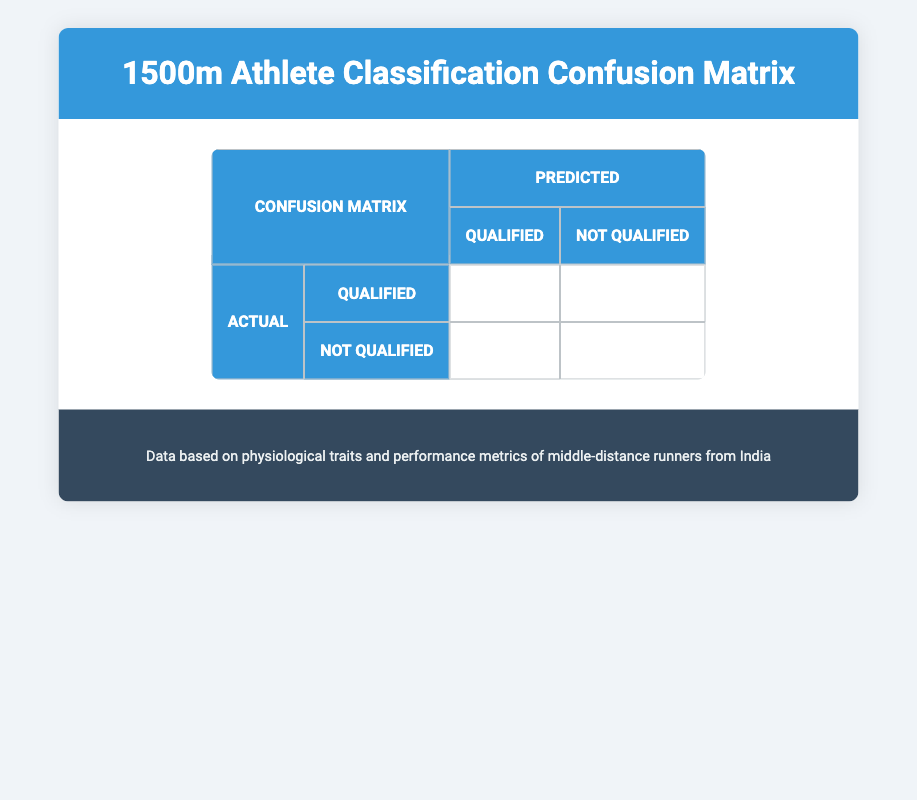What is the total number of athletes that qualified for the event? There are 4 athletes classified as "Qualified" in the confusion matrix, which is shown in the true positive section of the table.
Answer: 4 What is the total number of athletes that did not qualify for the event? Similarly, there are 4 athletes classified as "Not Qualified," indicated in the true negative section of the table.
Answer: 4 Is it true that all athletes who qualified were correctly predicted as "Qualified"? Yes, the confusion matrix shows that there are 4 true positives (qualified correctly) and 0 false negatives (qualified but predicted as not qualified). Therefore, 4 out of 4 qualified athletes were correctly predicted.
Answer: Yes What is the total number of incorrect predictions made? The confusion matrix indicates that there are 0 false positives (not qualified but predicted as qualified) and 0 false negatives (qualified but predicted as not qualified), leading to a total of 0 incorrect predictions.
Answer: 0 What percentage of athletes were predicted correctly? To find this, we add true positives and true negatives (4 + 4 = 8) for total correct predictions, and since there are 8 total athletes, the percentage is (8/8)*100 = 100%.
Answer: 100% What is the ratio of qualified to not qualified athletes? There are 4 qualified athletes and 4 not qualified athletes, resulting in a ratio of 4:4, which simplifies to 1:1.
Answer: 1:1 How many athletes were falsely predicted as qualified? The confusion matrix shows that there are 0 false positives, meaning no athletes were falsely predicted as qualified.
Answer: 0 What can be inferred about the performance classification of the athletes based on this matrix? The confusion matrix indicates a perfect classification, with all qualified athletes accurately predicted and all not qualified accurately predicted, highlighting the effectiveness of the classification criteria used for this assessment.
Answer: Perfect classification 